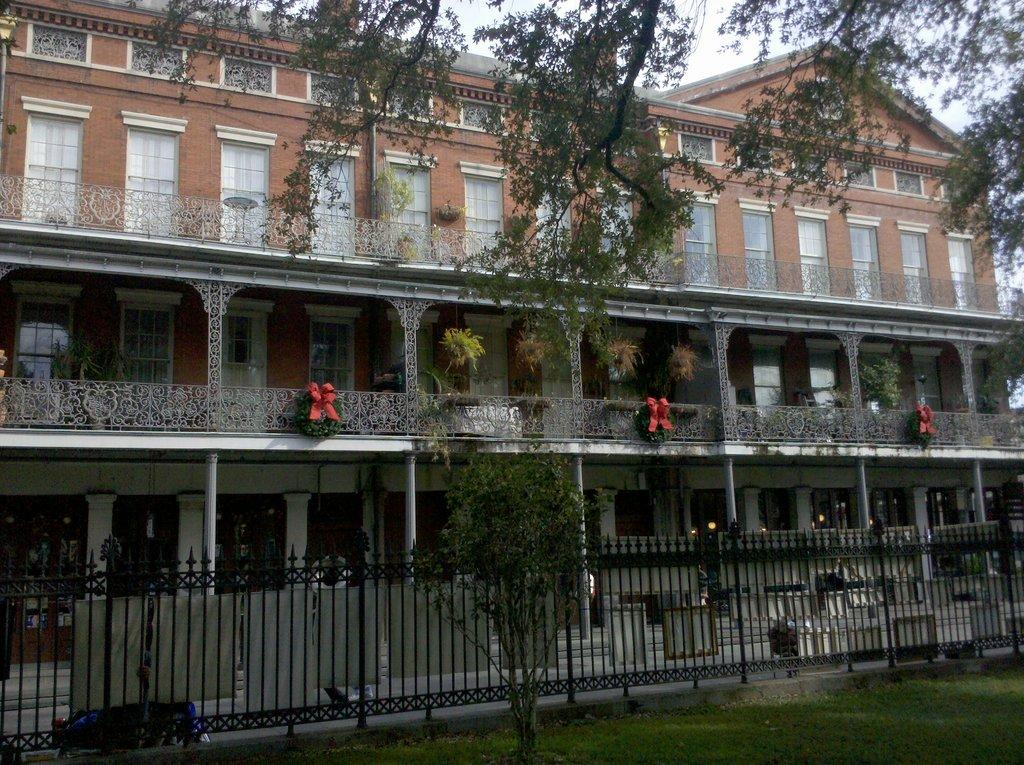What type of vegetation is present on the ground in the image? There is grass on the ground in the image. What other natural element can be seen in the image? There is a tree in the image. What type of structure is present in the image? There is a fence in the image. What is the color of the fence? The fence is black in color. What can be seen in the background of the image? There is a building in the background of the image. Can you see the person's brain in the image? There is no person or brain visible in the image; it primarily features natural elements and a fence. 